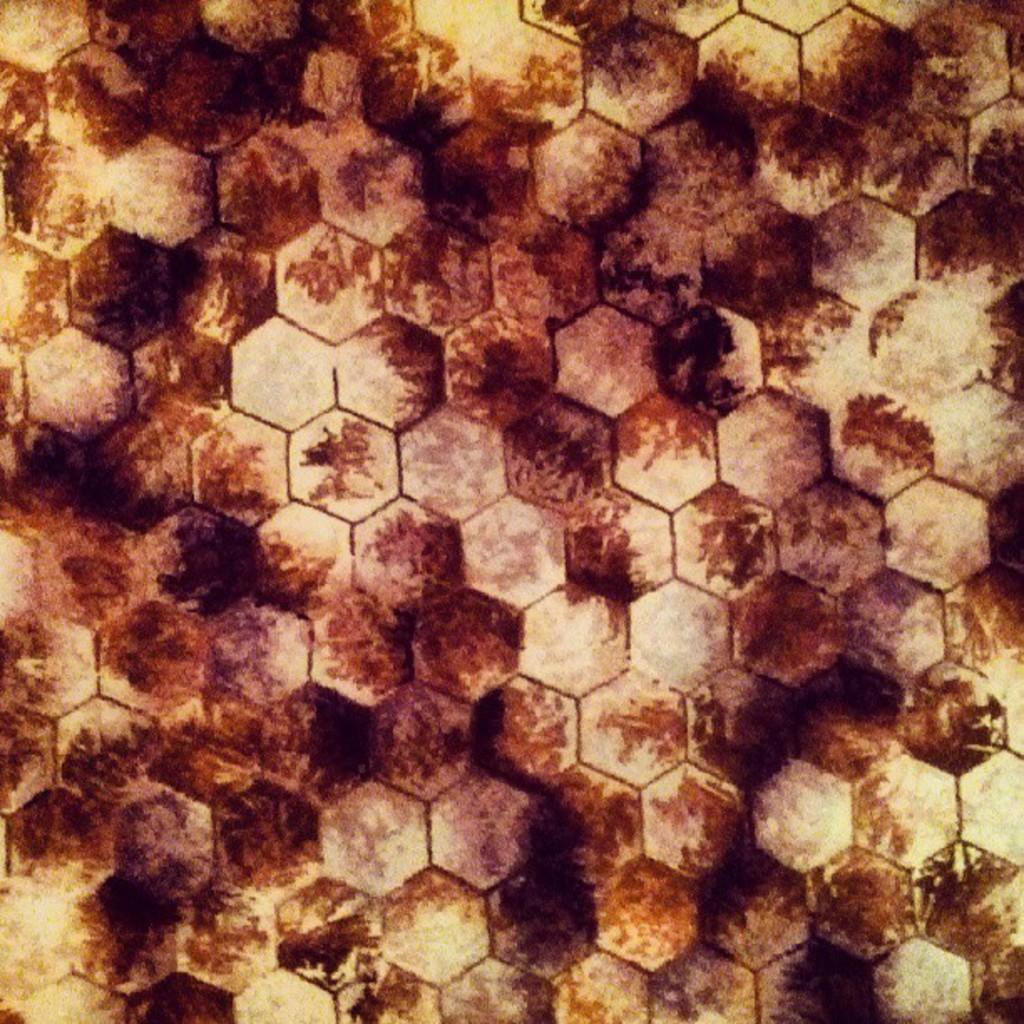How would you summarize this image in a sentence or two? In this picture we can see a surface with some marks on it. 